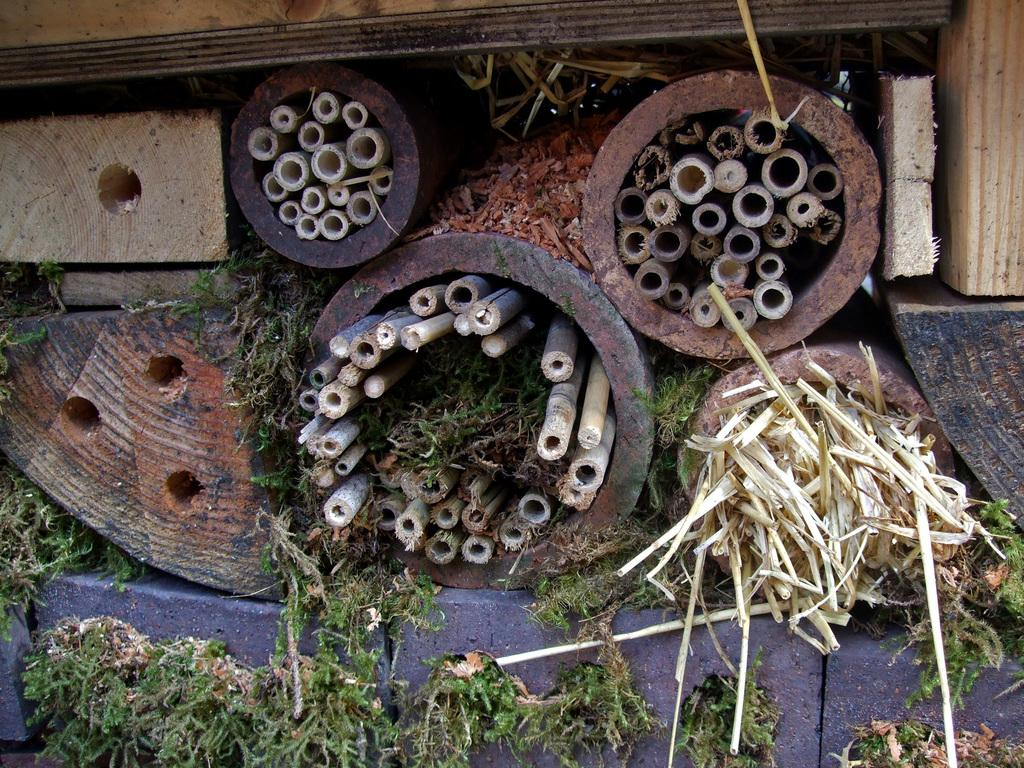What type of objects are made of wood in the image? There are wooden sticks in the image. What color is the grass in the image? The grass in the image is green. What type of music can be heard playing in the background of the image? There is no music present in the image, as it is a still image and does not have any sound. 